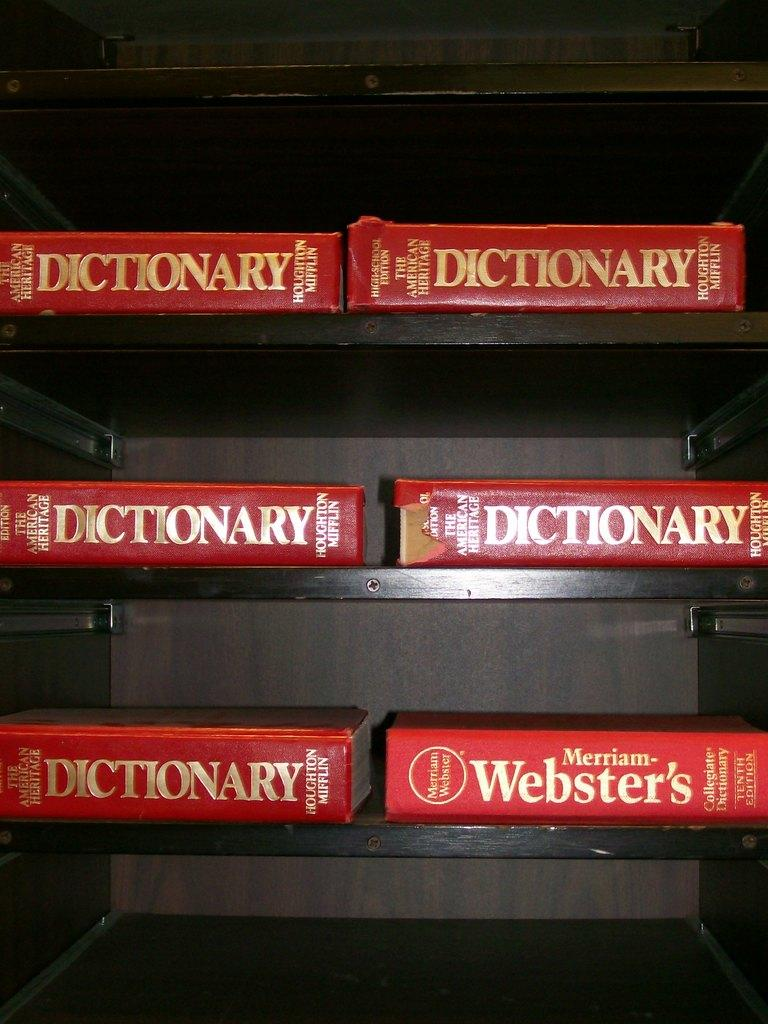<image>
Write a terse but informative summary of the picture. Six red Webster's dictionaries in gold lettering on black shelves. 